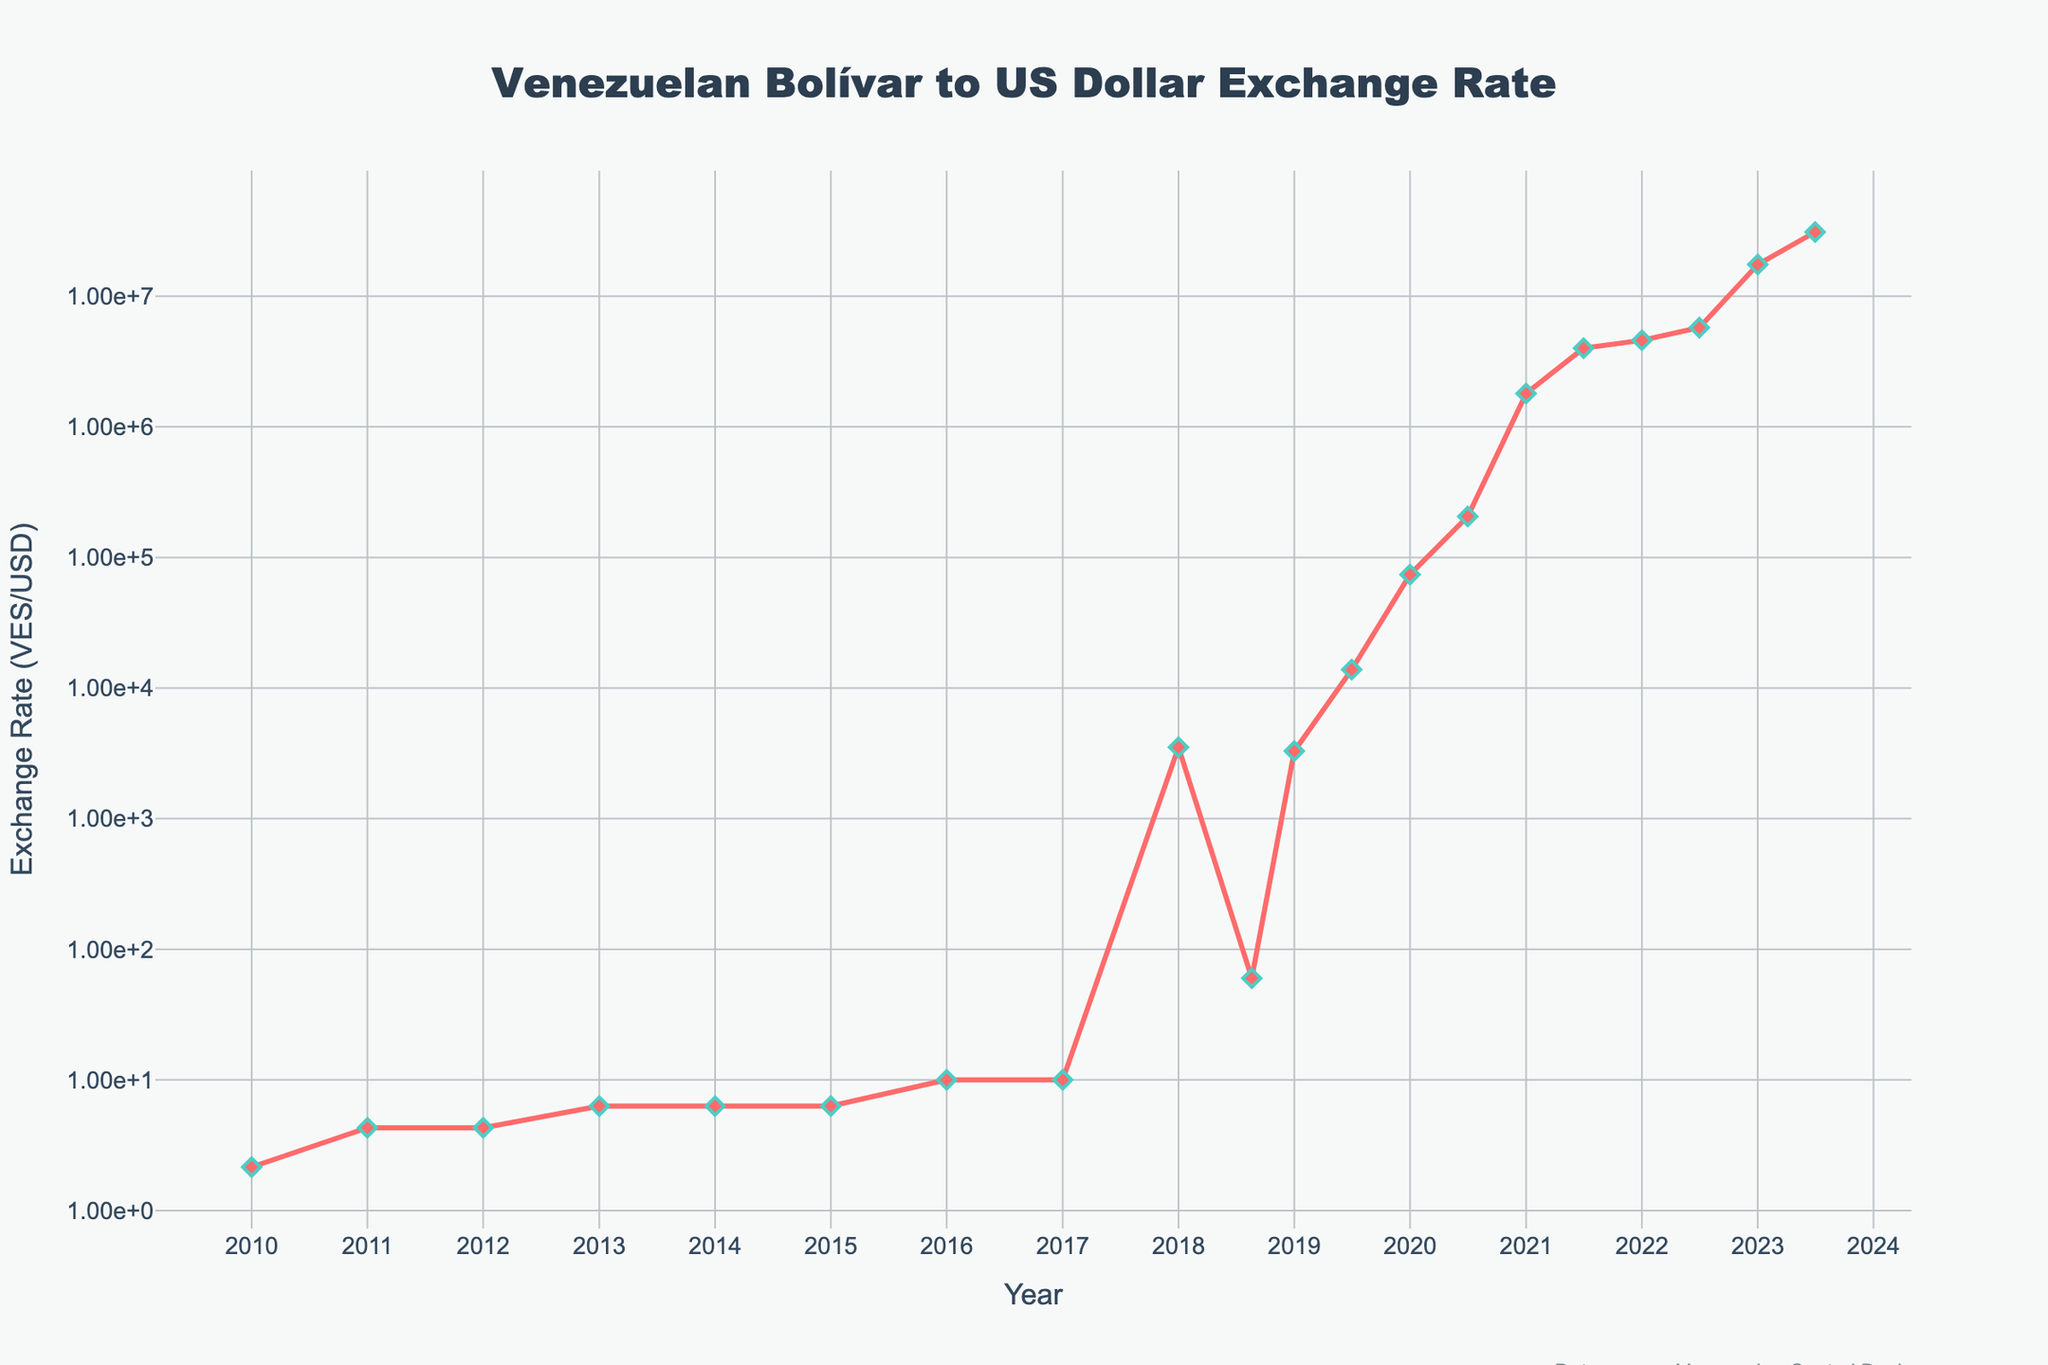Which year shows the highest exchange rate in the chart? The chart shows the VES/USD exchange rate peaking in mid-2023 (July 2023) at 31,000,000. This is the highest point in the entire data series.
Answer: 2023 How does the exchange rate in 2011 compare to that in 2017? In 2011, the exchange rate is depicted as 4.30 VES/USD, while in 2017, it is 10.00 VES/USD. By comparing these, we can see that the 2017 rate was more than double the 2011 rate.
Answer: The exchange rate in 2017 is higher What is the difference in the exchange rate between January 2021 and January 2022? In January 2021, the exchange rate is 1,800,000 VES/USD, and in January 2022, it is 4,600,000 VES/USD. The difference is calculated as 4,600,000 - 1,800,000, which equals 2,800,000.
Answer: 2,800,000 Compare the exchange rate from 2016 to 2018 and describe the trend. In 2016, the exchange rate is 10.00 VES/USD. By 2018, there are two data points: January with 3,523.00 and August with 60.00 due to a redenomination. The trend shows a drastic increase initially, representing hyperinflation followed by redenomination.
Answer: The exchange rate showed an immense increase What is the average exchange rate from 2010 to 2013? The rates from 2010 to 2013 are 2.15, 4.30, 4.30, and 6.30 respectively. The average is calculated as (2.15 + 4.30 + 4.30 + 6.30) / 4, which equals 4.2625.
Answer: 4.2625 How did the exchange rate change between January 2020 and July 2020? In January 2020, the exchange rate is 74,000 VES/USD, and in July 2020, it reaches 206,000 VES/USD. The change is calculated as 206,000 - 74,000, which equals 132,000.
Answer: It increased by 132,000 What is the visual appearance of the line between January 2021 and July 2021? The line representing the exchange rate between January 2021 (1,800,000 VES/USD) and July 2021 (4,000,000 VES/USD) is steeply rising, indicating a sharp increase in the exchange rate during this period.
Answer: Steeply rising By how much did the exchange rate increase from July 2022 to January 2023? The exchange rate in July 2022 is 5,750,000 VES/USD, and in January 2023, it is 17,500,000 VES/USD. The increase is calculated as 17,500,000 - 5,750,000, which equals 11,750,000.
Answer: 11,750,000 How much did the exchange rate increase by from January 2019 to July 2019? In January 2019, the exchange rate is 3,290.00 VES/USD and by July 2019, it is 13,830.00 VES/USD. The increase is 13,830.00 - 3,290.00, which equals 10,540.00.
Answer: 10,540.00 